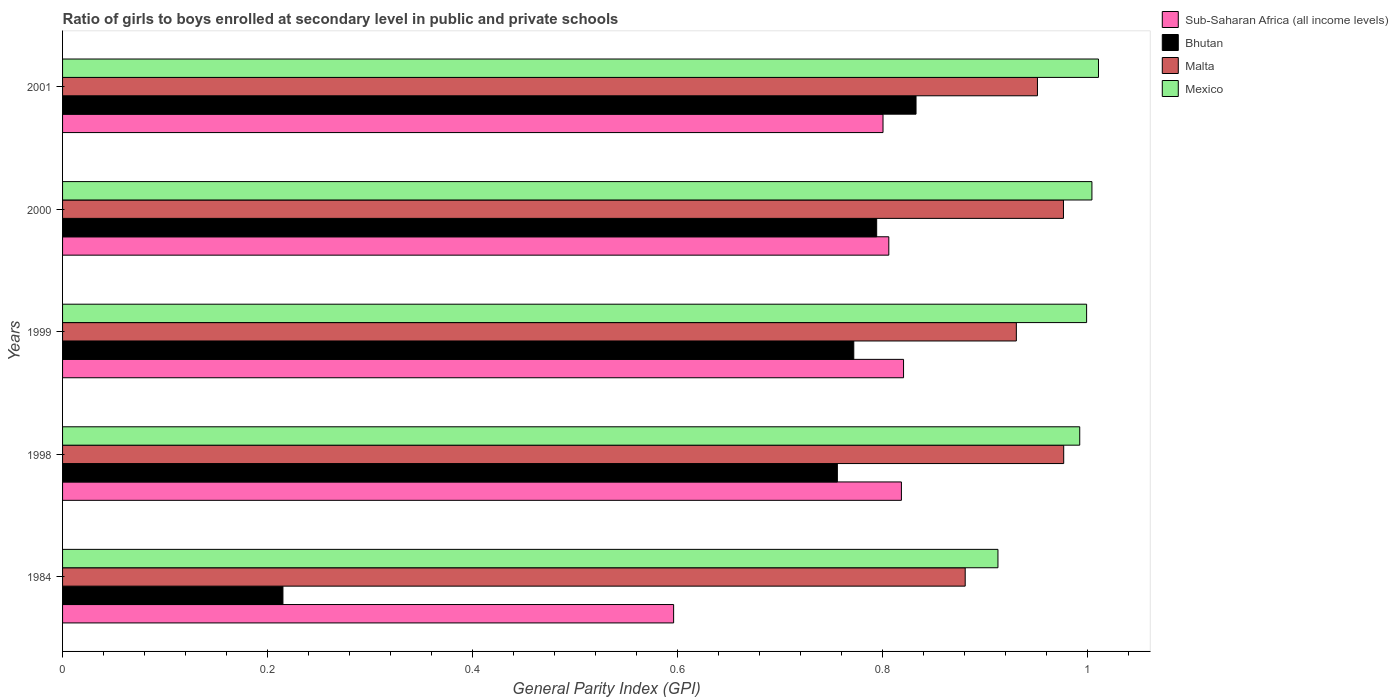How many groups of bars are there?
Your answer should be very brief. 5. Are the number of bars per tick equal to the number of legend labels?
Provide a short and direct response. Yes. What is the general parity index in Mexico in 1998?
Your response must be concise. 0.99. Across all years, what is the maximum general parity index in Sub-Saharan Africa (all income levels)?
Your answer should be very brief. 0.82. Across all years, what is the minimum general parity index in Bhutan?
Your answer should be very brief. 0.21. In which year was the general parity index in Mexico maximum?
Keep it short and to the point. 2001. In which year was the general parity index in Bhutan minimum?
Your response must be concise. 1984. What is the total general parity index in Bhutan in the graph?
Offer a terse response. 3.37. What is the difference between the general parity index in Sub-Saharan Africa (all income levels) in 1998 and that in 2000?
Make the answer very short. 0.01. What is the difference between the general parity index in Mexico in 2000 and the general parity index in Sub-Saharan Africa (all income levels) in 2001?
Make the answer very short. 0.2. What is the average general parity index in Sub-Saharan Africa (all income levels) per year?
Keep it short and to the point. 0.77. In the year 1999, what is the difference between the general parity index in Sub-Saharan Africa (all income levels) and general parity index in Malta?
Offer a terse response. -0.11. What is the ratio of the general parity index in Sub-Saharan Africa (all income levels) in 1998 to that in 2001?
Give a very brief answer. 1.02. Is the general parity index in Sub-Saharan Africa (all income levels) in 1984 less than that in 1999?
Make the answer very short. Yes. What is the difference between the highest and the second highest general parity index in Malta?
Provide a succinct answer. 0. What is the difference between the highest and the lowest general parity index in Malta?
Offer a terse response. 0.1. Is the sum of the general parity index in Mexico in 1998 and 2001 greater than the maximum general parity index in Sub-Saharan Africa (all income levels) across all years?
Your answer should be very brief. Yes. Is it the case that in every year, the sum of the general parity index in Mexico and general parity index in Bhutan is greater than the sum of general parity index in Malta and general parity index in Sub-Saharan Africa (all income levels)?
Your response must be concise. No. What does the 4th bar from the top in 1984 represents?
Make the answer very short. Sub-Saharan Africa (all income levels). What does the 2nd bar from the bottom in 1999 represents?
Provide a short and direct response. Bhutan. Is it the case that in every year, the sum of the general parity index in Bhutan and general parity index in Mexico is greater than the general parity index in Malta?
Keep it short and to the point. Yes. How many bars are there?
Provide a short and direct response. 20. How many years are there in the graph?
Provide a succinct answer. 5. What is the difference between two consecutive major ticks on the X-axis?
Offer a terse response. 0.2. Are the values on the major ticks of X-axis written in scientific E-notation?
Give a very brief answer. No. Does the graph contain any zero values?
Give a very brief answer. No. How are the legend labels stacked?
Give a very brief answer. Vertical. What is the title of the graph?
Your answer should be compact. Ratio of girls to boys enrolled at secondary level in public and private schools. What is the label or title of the X-axis?
Your answer should be very brief. General Parity Index (GPI). What is the General Parity Index (GPI) in Sub-Saharan Africa (all income levels) in 1984?
Offer a terse response. 0.6. What is the General Parity Index (GPI) of Bhutan in 1984?
Offer a terse response. 0.21. What is the General Parity Index (GPI) of Malta in 1984?
Provide a short and direct response. 0.88. What is the General Parity Index (GPI) of Mexico in 1984?
Keep it short and to the point. 0.91. What is the General Parity Index (GPI) in Sub-Saharan Africa (all income levels) in 1998?
Your answer should be very brief. 0.82. What is the General Parity Index (GPI) in Bhutan in 1998?
Make the answer very short. 0.76. What is the General Parity Index (GPI) in Malta in 1998?
Offer a terse response. 0.98. What is the General Parity Index (GPI) in Mexico in 1998?
Provide a succinct answer. 0.99. What is the General Parity Index (GPI) of Sub-Saharan Africa (all income levels) in 1999?
Make the answer very short. 0.82. What is the General Parity Index (GPI) of Bhutan in 1999?
Offer a very short reply. 0.77. What is the General Parity Index (GPI) in Malta in 1999?
Ensure brevity in your answer.  0.93. What is the General Parity Index (GPI) of Mexico in 1999?
Offer a terse response. 1. What is the General Parity Index (GPI) of Sub-Saharan Africa (all income levels) in 2000?
Offer a terse response. 0.81. What is the General Parity Index (GPI) of Bhutan in 2000?
Offer a terse response. 0.79. What is the General Parity Index (GPI) in Malta in 2000?
Make the answer very short. 0.98. What is the General Parity Index (GPI) of Mexico in 2000?
Make the answer very short. 1. What is the General Parity Index (GPI) in Sub-Saharan Africa (all income levels) in 2001?
Your answer should be very brief. 0.8. What is the General Parity Index (GPI) of Bhutan in 2001?
Give a very brief answer. 0.83. What is the General Parity Index (GPI) of Malta in 2001?
Provide a short and direct response. 0.95. What is the General Parity Index (GPI) in Mexico in 2001?
Keep it short and to the point. 1.01. Across all years, what is the maximum General Parity Index (GPI) in Sub-Saharan Africa (all income levels)?
Offer a terse response. 0.82. Across all years, what is the maximum General Parity Index (GPI) of Bhutan?
Offer a terse response. 0.83. Across all years, what is the maximum General Parity Index (GPI) of Malta?
Your answer should be very brief. 0.98. Across all years, what is the maximum General Parity Index (GPI) in Mexico?
Your answer should be compact. 1.01. Across all years, what is the minimum General Parity Index (GPI) of Sub-Saharan Africa (all income levels)?
Your response must be concise. 0.6. Across all years, what is the minimum General Parity Index (GPI) in Bhutan?
Keep it short and to the point. 0.21. Across all years, what is the minimum General Parity Index (GPI) in Malta?
Provide a short and direct response. 0.88. Across all years, what is the minimum General Parity Index (GPI) of Mexico?
Ensure brevity in your answer.  0.91. What is the total General Parity Index (GPI) in Sub-Saharan Africa (all income levels) in the graph?
Your answer should be very brief. 3.84. What is the total General Parity Index (GPI) of Bhutan in the graph?
Offer a very short reply. 3.37. What is the total General Parity Index (GPI) of Malta in the graph?
Give a very brief answer. 4.72. What is the total General Parity Index (GPI) in Mexico in the graph?
Ensure brevity in your answer.  4.92. What is the difference between the General Parity Index (GPI) of Sub-Saharan Africa (all income levels) in 1984 and that in 1998?
Provide a succinct answer. -0.22. What is the difference between the General Parity Index (GPI) of Bhutan in 1984 and that in 1998?
Offer a terse response. -0.54. What is the difference between the General Parity Index (GPI) in Malta in 1984 and that in 1998?
Make the answer very short. -0.1. What is the difference between the General Parity Index (GPI) of Mexico in 1984 and that in 1998?
Your response must be concise. -0.08. What is the difference between the General Parity Index (GPI) in Sub-Saharan Africa (all income levels) in 1984 and that in 1999?
Offer a very short reply. -0.22. What is the difference between the General Parity Index (GPI) of Bhutan in 1984 and that in 1999?
Provide a succinct answer. -0.56. What is the difference between the General Parity Index (GPI) in Malta in 1984 and that in 1999?
Provide a succinct answer. -0.05. What is the difference between the General Parity Index (GPI) in Mexico in 1984 and that in 1999?
Your response must be concise. -0.09. What is the difference between the General Parity Index (GPI) in Sub-Saharan Africa (all income levels) in 1984 and that in 2000?
Your response must be concise. -0.21. What is the difference between the General Parity Index (GPI) in Bhutan in 1984 and that in 2000?
Give a very brief answer. -0.58. What is the difference between the General Parity Index (GPI) in Malta in 1984 and that in 2000?
Provide a succinct answer. -0.1. What is the difference between the General Parity Index (GPI) in Mexico in 1984 and that in 2000?
Provide a short and direct response. -0.09. What is the difference between the General Parity Index (GPI) of Sub-Saharan Africa (all income levels) in 1984 and that in 2001?
Your response must be concise. -0.2. What is the difference between the General Parity Index (GPI) in Bhutan in 1984 and that in 2001?
Offer a very short reply. -0.62. What is the difference between the General Parity Index (GPI) in Malta in 1984 and that in 2001?
Your answer should be very brief. -0.07. What is the difference between the General Parity Index (GPI) of Mexico in 1984 and that in 2001?
Offer a terse response. -0.1. What is the difference between the General Parity Index (GPI) of Sub-Saharan Africa (all income levels) in 1998 and that in 1999?
Keep it short and to the point. -0. What is the difference between the General Parity Index (GPI) of Bhutan in 1998 and that in 1999?
Ensure brevity in your answer.  -0.02. What is the difference between the General Parity Index (GPI) in Malta in 1998 and that in 1999?
Offer a very short reply. 0.05. What is the difference between the General Parity Index (GPI) in Mexico in 1998 and that in 1999?
Provide a short and direct response. -0.01. What is the difference between the General Parity Index (GPI) in Sub-Saharan Africa (all income levels) in 1998 and that in 2000?
Make the answer very short. 0.01. What is the difference between the General Parity Index (GPI) of Bhutan in 1998 and that in 2000?
Make the answer very short. -0.04. What is the difference between the General Parity Index (GPI) in Mexico in 1998 and that in 2000?
Make the answer very short. -0.01. What is the difference between the General Parity Index (GPI) in Sub-Saharan Africa (all income levels) in 1998 and that in 2001?
Make the answer very short. 0.02. What is the difference between the General Parity Index (GPI) of Bhutan in 1998 and that in 2001?
Your answer should be compact. -0.08. What is the difference between the General Parity Index (GPI) in Malta in 1998 and that in 2001?
Your answer should be compact. 0.03. What is the difference between the General Parity Index (GPI) in Mexico in 1998 and that in 2001?
Provide a succinct answer. -0.02. What is the difference between the General Parity Index (GPI) in Sub-Saharan Africa (all income levels) in 1999 and that in 2000?
Keep it short and to the point. 0.01. What is the difference between the General Parity Index (GPI) in Bhutan in 1999 and that in 2000?
Your answer should be compact. -0.02. What is the difference between the General Parity Index (GPI) in Malta in 1999 and that in 2000?
Offer a terse response. -0.05. What is the difference between the General Parity Index (GPI) in Mexico in 1999 and that in 2000?
Your answer should be compact. -0.01. What is the difference between the General Parity Index (GPI) of Bhutan in 1999 and that in 2001?
Provide a succinct answer. -0.06. What is the difference between the General Parity Index (GPI) of Malta in 1999 and that in 2001?
Provide a short and direct response. -0.02. What is the difference between the General Parity Index (GPI) in Mexico in 1999 and that in 2001?
Your answer should be very brief. -0.01. What is the difference between the General Parity Index (GPI) in Sub-Saharan Africa (all income levels) in 2000 and that in 2001?
Give a very brief answer. 0.01. What is the difference between the General Parity Index (GPI) in Bhutan in 2000 and that in 2001?
Offer a very short reply. -0.04. What is the difference between the General Parity Index (GPI) of Malta in 2000 and that in 2001?
Give a very brief answer. 0.03. What is the difference between the General Parity Index (GPI) in Mexico in 2000 and that in 2001?
Provide a short and direct response. -0.01. What is the difference between the General Parity Index (GPI) in Sub-Saharan Africa (all income levels) in 1984 and the General Parity Index (GPI) in Bhutan in 1998?
Make the answer very short. -0.16. What is the difference between the General Parity Index (GPI) in Sub-Saharan Africa (all income levels) in 1984 and the General Parity Index (GPI) in Malta in 1998?
Make the answer very short. -0.38. What is the difference between the General Parity Index (GPI) in Sub-Saharan Africa (all income levels) in 1984 and the General Parity Index (GPI) in Mexico in 1998?
Give a very brief answer. -0.4. What is the difference between the General Parity Index (GPI) in Bhutan in 1984 and the General Parity Index (GPI) in Malta in 1998?
Keep it short and to the point. -0.76. What is the difference between the General Parity Index (GPI) in Bhutan in 1984 and the General Parity Index (GPI) in Mexico in 1998?
Ensure brevity in your answer.  -0.78. What is the difference between the General Parity Index (GPI) of Malta in 1984 and the General Parity Index (GPI) of Mexico in 1998?
Provide a short and direct response. -0.11. What is the difference between the General Parity Index (GPI) in Sub-Saharan Africa (all income levels) in 1984 and the General Parity Index (GPI) in Bhutan in 1999?
Provide a succinct answer. -0.18. What is the difference between the General Parity Index (GPI) of Sub-Saharan Africa (all income levels) in 1984 and the General Parity Index (GPI) of Malta in 1999?
Your response must be concise. -0.33. What is the difference between the General Parity Index (GPI) in Sub-Saharan Africa (all income levels) in 1984 and the General Parity Index (GPI) in Mexico in 1999?
Provide a succinct answer. -0.4. What is the difference between the General Parity Index (GPI) in Bhutan in 1984 and the General Parity Index (GPI) in Malta in 1999?
Your answer should be very brief. -0.72. What is the difference between the General Parity Index (GPI) of Bhutan in 1984 and the General Parity Index (GPI) of Mexico in 1999?
Make the answer very short. -0.78. What is the difference between the General Parity Index (GPI) of Malta in 1984 and the General Parity Index (GPI) of Mexico in 1999?
Ensure brevity in your answer.  -0.12. What is the difference between the General Parity Index (GPI) of Sub-Saharan Africa (all income levels) in 1984 and the General Parity Index (GPI) of Bhutan in 2000?
Your answer should be very brief. -0.2. What is the difference between the General Parity Index (GPI) in Sub-Saharan Africa (all income levels) in 1984 and the General Parity Index (GPI) in Malta in 2000?
Provide a short and direct response. -0.38. What is the difference between the General Parity Index (GPI) in Sub-Saharan Africa (all income levels) in 1984 and the General Parity Index (GPI) in Mexico in 2000?
Ensure brevity in your answer.  -0.41. What is the difference between the General Parity Index (GPI) of Bhutan in 1984 and the General Parity Index (GPI) of Malta in 2000?
Give a very brief answer. -0.76. What is the difference between the General Parity Index (GPI) of Bhutan in 1984 and the General Parity Index (GPI) of Mexico in 2000?
Ensure brevity in your answer.  -0.79. What is the difference between the General Parity Index (GPI) of Malta in 1984 and the General Parity Index (GPI) of Mexico in 2000?
Keep it short and to the point. -0.12. What is the difference between the General Parity Index (GPI) in Sub-Saharan Africa (all income levels) in 1984 and the General Parity Index (GPI) in Bhutan in 2001?
Ensure brevity in your answer.  -0.24. What is the difference between the General Parity Index (GPI) of Sub-Saharan Africa (all income levels) in 1984 and the General Parity Index (GPI) of Malta in 2001?
Keep it short and to the point. -0.35. What is the difference between the General Parity Index (GPI) in Sub-Saharan Africa (all income levels) in 1984 and the General Parity Index (GPI) in Mexico in 2001?
Keep it short and to the point. -0.41. What is the difference between the General Parity Index (GPI) in Bhutan in 1984 and the General Parity Index (GPI) in Malta in 2001?
Ensure brevity in your answer.  -0.74. What is the difference between the General Parity Index (GPI) of Bhutan in 1984 and the General Parity Index (GPI) of Mexico in 2001?
Your answer should be compact. -0.8. What is the difference between the General Parity Index (GPI) of Malta in 1984 and the General Parity Index (GPI) of Mexico in 2001?
Your answer should be very brief. -0.13. What is the difference between the General Parity Index (GPI) in Sub-Saharan Africa (all income levels) in 1998 and the General Parity Index (GPI) in Bhutan in 1999?
Your response must be concise. 0.05. What is the difference between the General Parity Index (GPI) in Sub-Saharan Africa (all income levels) in 1998 and the General Parity Index (GPI) in Malta in 1999?
Provide a short and direct response. -0.11. What is the difference between the General Parity Index (GPI) in Sub-Saharan Africa (all income levels) in 1998 and the General Parity Index (GPI) in Mexico in 1999?
Provide a short and direct response. -0.18. What is the difference between the General Parity Index (GPI) in Bhutan in 1998 and the General Parity Index (GPI) in Malta in 1999?
Your answer should be very brief. -0.17. What is the difference between the General Parity Index (GPI) of Bhutan in 1998 and the General Parity Index (GPI) of Mexico in 1999?
Your response must be concise. -0.24. What is the difference between the General Parity Index (GPI) in Malta in 1998 and the General Parity Index (GPI) in Mexico in 1999?
Offer a very short reply. -0.02. What is the difference between the General Parity Index (GPI) in Sub-Saharan Africa (all income levels) in 1998 and the General Parity Index (GPI) in Bhutan in 2000?
Provide a short and direct response. 0.02. What is the difference between the General Parity Index (GPI) of Sub-Saharan Africa (all income levels) in 1998 and the General Parity Index (GPI) of Malta in 2000?
Make the answer very short. -0.16. What is the difference between the General Parity Index (GPI) of Sub-Saharan Africa (all income levels) in 1998 and the General Parity Index (GPI) of Mexico in 2000?
Make the answer very short. -0.19. What is the difference between the General Parity Index (GPI) of Bhutan in 1998 and the General Parity Index (GPI) of Malta in 2000?
Provide a succinct answer. -0.22. What is the difference between the General Parity Index (GPI) in Bhutan in 1998 and the General Parity Index (GPI) in Mexico in 2000?
Provide a succinct answer. -0.25. What is the difference between the General Parity Index (GPI) in Malta in 1998 and the General Parity Index (GPI) in Mexico in 2000?
Your response must be concise. -0.03. What is the difference between the General Parity Index (GPI) in Sub-Saharan Africa (all income levels) in 1998 and the General Parity Index (GPI) in Bhutan in 2001?
Your answer should be very brief. -0.01. What is the difference between the General Parity Index (GPI) of Sub-Saharan Africa (all income levels) in 1998 and the General Parity Index (GPI) of Malta in 2001?
Your response must be concise. -0.13. What is the difference between the General Parity Index (GPI) in Sub-Saharan Africa (all income levels) in 1998 and the General Parity Index (GPI) in Mexico in 2001?
Offer a very short reply. -0.19. What is the difference between the General Parity Index (GPI) of Bhutan in 1998 and the General Parity Index (GPI) of Malta in 2001?
Make the answer very short. -0.2. What is the difference between the General Parity Index (GPI) of Bhutan in 1998 and the General Parity Index (GPI) of Mexico in 2001?
Ensure brevity in your answer.  -0.25. What is the difference between the General Parity Index (GPI) of Malta in 1998 and the General Parity Index (GPI) of Mexico in 2001?
Keep it short and to the point. -0.03. What is the difference between the General Parity Index (GPI) of Sub-Saharan Africa (all income levels) in 1999 and the General Parity Index (GPI) of Bhutan in 2000?
Your answer should be very brief. 0.03. What is the difference between the General Parity Index (GPI) in Sub-Saharan Africa (all income levels) in 1999 and the General Parity Index (GPI) in Malta in 2000?
Your answer should be very brief. -0.16. What is the difference between the General Parity Index (GPI) in Sub-Saharan Africa (all income levels) in 1999 and the General Parity Index (GPI) in Mexico in 2000?
Offer a terse response. -0.18. What is the difference between the General Parity Index (GPI) of Bhutan in 1999 and the General Parity Index (GPI) of Malta in 2000?
Offer a terse response. -0.2. What is the difference between the General Parity Index (GPI) of Bhutan in 1999 and the General Parity Index (GPI) of Mexico in 2000?
Provide a short and direct response. -0.23. What is the difference between the General Parity Index (GPI) in Malta in 1999 and the General Parity Index (GPI) in Mexico in 2000?
Your response must be concise. -0.07. What is the difference between the General Parity Index (GPI) of Sub-Saharan Africa (all income levels) in 1999 and the General Parity Index (GPI) of Bhutan in 2001?
Your response must be concise. -0.01. What is the difference between the General Parity Index (GPI) in Sub-Saharan Africa (all income levels) in 1999 and the General Parity Index (GPI) in Malta in 2001?
Your answer should be compact. -0.13. What is the difference between the General Parity Index (GPI) in Sub-Saharan Africa (all income levels) in 1999 and the General Parity Index (GPI) in Mexico in 2001?
Provide a succinct answer. -0.19. What is the difference between the General Parity Index (GPI) in Bhutan in 1999 and the General Parity Index (GPI) in Malta in 2001?
Your answer should be very brief. -0.18. What is the difference between the General Parity Index (GPI) in Bhutan in 1999 and the General Parity Index (GPI) in Mexico in 2001?
Give a very brief answer. -0.24. What is the difference between the General Parity Index (GPI) of Malta in 1999 and the General Parity Index (GPI) of Mexico in 2001?
Make the answer very short. -0.08. What is the difference between the General Parity Index (GPI) in Sub-Saharan Africa (all income levels) in 2000 and the General Parity Index (GPI) in Bhutan in 2001?
Offer a very short reply. -0.03. What is the difference between the General Parity Index (GPI) of Sub-Saharan Africa (all income levels) in 2000 and the General Parity Index (GPI) of Malta in 2001?
Your answer should be compact. -0.14. What is the difference between the General Parity Index (GPI) in Sub-Saharan Africa (all income levels) in 2000 and the General Parity Index (GPI) in Mexico in 2001?
Provide a succinct answer. -0.2. What is the difference between the General Parity Index (GPI) of Bhutan in 2000 and the General Parity Index (GPI) of Malta in 2001?
Your answer should be very brief. -0.16. What is the difference between the General Parity Index (GPI) of Bhutan in 2000 and the General Parity Index (GPI) of Mexico in 2001?
Keep it short and to the point. -0.22. What is the difference between the General Parity Index (GPI) in Malta in 2000 and the General Parity Index (GPI) in Mexico in 2001?
Your answer should be very brief. -0.03. What is the average General Parity Index (GPI) in Sub-Saharan Africa (all income levels) per year?
Provide a short and direct response. 0.77. What is the average General Parity Index (GPI) of Bhutan per year?
Make the answer very short. 0.67. What is the average General Parity Index (GPI) in Malta per year?
Give a very brief answer. 0.94. What is the average General Parity Index (GPI) of Mexico per year?
Provide a succinct answer. 0.98. In the year 1984, what is the difference between the General Parity Index (GPI) of Sub-Saharan Africa (all income levels) and General Parity Index (GPI) of Bhutan?
Offer a terse response. 0.38. In the year 1984, what is the difference between the General Parity Index (GPI) in Sub-Saharan Africa (all income levels) and General Parity Index (GPI) in Malta?
Your answer should be very brief. -0.28. In the year 1984, what is the difference between the General Parity Index (GPI) of Sub-Saharan Africa (all income levels) and General Parity Index (GPI) of Mexico?
Offer a very short reply. -0.32. In the year 1984, what is the difference between the General Parity Index (GPI) of Bhutan and General Parity Index (GPI) of Malta?
Provide a succinct answer. -0.67. In the year 1984, what is the difference between the General Parity Index (GPI) in Bhutan and General Parity Index (GPI) in Mexico?
Offer a terse response. -0.7. In the year 1984, what is the difference between the General Parity Index (GPI) in Malta and General Parity Index (GPI) in Mexico?
Offer a terse response. -0.03. In the year 1998, what is the difference between the General Parity Index (GPI) of Sub-Saharan Africa (all income levels) and General Parity Index (GPI) of Bhutan?
Give a very brief answer. 0.06. In the year 1998, what is the difference between the General Parity Index (GPI) in Sub-Saharan Africa (all income levels) and General Parity Index (GPI) in Malta?
Ensure brevity in your answer.  -0.16. In the year 1998, what is the difference between the General Parity Index (GPI) in Sub-Saharan Africa (all income levels) and General Parity Index (GPI) in Mexico?
Keep it short and to the point. -0.17. In the year 1998, what is the difference between the General Parity Index (GPI) in Bhutan and General Parity Index (GPI) in Malta?
Ensure brevity in your answer.  -0.22. In the year 1998, what is the difference between the General Parity Index (GPI) in Bhutan and General Parity Index (GPI) in Mexico?
Provide a short and direct response. -0.24. In the year 1998, what is the difference between the General Parity Index (GPI) of Malta and General Parity Index (GPI) of Mexico?
Provide a short and direct response. -0.02. In the year 1999, what is the difference between the General Parity Index (GPI) of Sub-Saharan Africa (all income levels) and General Parity Index (GPI) of Bhutan?
Provide a short and direct response. 0.05. In the year 1999, what is the difference between the General Parity Index (GPI) in Sub-Saharan Africa (all income levels) and General Parity Index (GPI) in Malta?
Keep it short and to the point. -0.11. In the year 1999, what is the difference between the General Parity Index (GPI) in Sub-Saharan Africa (all income levels) and General Parity Index (GPI) in Mexico?
Provide a short and direct response. -0.18. In the year 1999, what is the difference between the General Parity Index (GPI) in Bhutan and General Parity Index (GPI) in Malta?
Provide a short and direct response. -0.16. In the year 1999, what is the difference between the General Parity Index (GPI) of Bhutan and General Parity Index (GPI) of Mexico?
Your response must be concise. -0.23. In the year 1999, what is the difference between the General Parity Index (GPI) of Malta and General Parity Index (GPI) of Mexico?
Ensure brevity in your answer.  -0.07. In the year 2000, what is the difference between the General Parity Index (GPI) in Sub-Saharan Africa (all income levels) and General Parity Index (GPI) in Bhutan?
Ensure brevity in your answer.  0.01. In the year 2000, what is the difference between the General Parity Index (GPI) of Sub-Saharan Africa (all income levels) and General Parity Index (GPI) of Malta?
Offer a terse response. -0.17. In the year 2000, what is the difference between the General Parity Index (GPI) of Sub-Saharan Africa (all income levels) and General Parity Index (GPI) of Mexico?
Your answer should be very brief. -0.2. In the year 2000, what is the difference between the General Parity Index (GPI) of Bhutan and General Parity Index (GPI) of Malta?
Keep it short and to the point. -0.18. In the year 2000, what is the difference between the General Parity Index (GPI) of Bhutan and General Parity Index (GPI) of Mexico?
Provide a succinct answer. -0.21. In the year 2000, what is the difference between the General Parity Index (GPI) of Malta and General Parity Index (GPI) of Mexico?
Make the answer very short. -0.03. In the year 2001, what is the difference between the General Parity Index (GPI) of Sub-Saharan Africa (all income levels) and General Parity Index (GPI) of Bhutan?
Provide a succinct answer. -0.03. In the year 2001, what is the difference between the General Parity Index (GPI) in Sub-Saharan Africa (all income levels) and General Parity Index (GPI) in Malta?
Make the answer very short. -0.15. In the year 2001, what is the difference between the General Parity Index (GPI) of Sub-Saharan Africa (all income levels) and General Parity Index (GPI) of Mexico?
Give a very brief answer. -0.21. In the year 2001, what is the difference between the General Parity Index (GPI) of Bhutan and General Parity Index (GPI) of Malta?
Provide a succinct answer. -0.12. In the year 2001, what is the difference between the General Parity Index (GPI) of Bhutan and General Parity Index (GPI) of Mexico?
Provide a short and direct response. -0.18. In the year 2001, what is the difference between the General Parity Index (GPI) of Malta and General Parity Index (GPI) of Mexico?
Ensure brevity in your answer.  -0.06. What is the ratio of the General Parity Index (GPI) of Sub-Saharan Africa (all income levels) in 1984 to that in 1998?
Provide a short and direct response. 0.73. What is the ratio of the General Parity Index (GPI) in Bhutan in 1984 to that in 1998?
Offer a terse response. 0.28. What is the ratio of the General Parity Index (GPI) in Malta in 1984 to that in 1998?
Make the answer very short. 0.9. What is the ratio of the General Parity Index (GPI) of Mexico in 1984 to that in 1998?
Provide a short and direct response. 0.92. What is the ratio of the General Parity Index (GPI) of Sub-Saharan Africa (all income levels) in 1984 to that in 1999?
Your response must be concise. 0.73. What is the ratio of the General Parity Index (GPI) in Bhutan in 1984 to that in 1999?
Provide a succinct answer. 0.28. What is the ratio of the General Parity Index (GPI) of Malta in 1984 to that in 1999?
Provide a short and direct response. 0.95. What is the ratio of the General Parity Index (GPI) of Mexico in 1984 to that in 1999?
Provide a succinct answer. 0.91. What is the ratio of the General Parity Index (GPI) of Sub-Saharan Africa (all income levels) in 1984 to that in 2000?
Your answer should be compact. 0.74. What is the ratio of the General Parity Index (GPI) of Bhutan in 1984 to that in 2000?
Give a very brief answer. 0.27. What is the ratio of the General Parity Index (GPI) in Malta in 1984 to that in 2000?
Your response must be concise. 0.9. What is the ratio of the General Parity Index (GPI) in Mexico in 1984 to that in 2000?
Give a very brief answer. 0.91. What is the ratio of the General Parity Index (GPI) of Sub-Saharan Africa (all income levels) in 1984 to that in 2001?
Keep it short and to the point. 0.74. What is the ratio of the General Parity Index (GPI) in Bhutan in 1984 to that in 2001?
Your answer should be very brief. 0.26. What is the ratio of the General Parity Index (GPI) in Malta in 1984 to that in 2001?
Provide a short and direct response. 0.93. What is the ratio of the General Parity Index (GPI) in Mexico in 1984 to that in 2001?
Provide a short and direct response. 0.9. What is the ratio of the General Parity Index (GPI) in Sub-Saharan Africa (all income levels) in 1998 to that in 1999?
Offer a very short reply. 1. What is the ratio of the General Parity Index (GPI) in Bhutan in 1998 to that in 1999?
Your response must be concise. 0.98. What is the ratio of the General Parity Index (GPI) in Malta in 1998 to that in 1999?
Ensure brevity in your answer.  1.05. What is the ratio of the General Parity Index (GPI) of Sub-Saharan Africa (all income levels) in 1998 to that in 2000?
Offer a terse response. 1.02. What is the ratio of the General Parity Index (GPI) in Bhutan in 1998 to that in 2000?
Offer a very short reply. 0.95. What is the ratio of the General Parity Index (GPI) of Malta in 1998 to that in 2000?
Ensure brevity in your answer.  1. What is the ratio of the General Parity Index (GPI) in Mexico in 1998 to that in 2000?
Offer a very short reply. 0.99. What is the ratio of the General Parity Index (GPI) of Sub-Saharan Africa (all income levels) in 1998 to that in 2001?
Keep it short and to the point. 1.02. What is the ratio of the General Parity Index (GPI) in Bhutan in 1998 to that in 2001?
Provide a short and direct response. 0.91. What is the ratio of the General Parity Index (GPI) of Malta in 1998 to that in 2001?
Your response must be concise. 1.03. What is the ratio of the General Parity Index (GPI) of Mexico in 1998 to that in 2001?
Provide a succinct answer. 0.98. What is the ratio of the General Parity Index (GPI) in Sub-Saharan Africa (all income levels) in 1999 to that in 2000?
Provide a short and direct response. 1.02. What is the ratio of the General Parity Index (GPI) in Bhutan in 1999 to that in 2000?
Ensure brevity in your answer.  0.97. What is the ratio of the General Parity Index (GPI) in Malta in 1999 to that in 2000?
Offer a terse response. 0.95. What is the ratio of the General Parity Index (GPI) of Sub-Saharan Africa (all income levels) in 1999 to that in 2001?
Provide a short and direct response. 1.02. What is the ratio of the General Parity Index (GPI) in Bhutan in 1999 to that in 2001?
Provide a short and direct response. 0.93. What is the ratio of the General Parity Index (GPI) of Malta in 1999 to that in 2001?
Offer a very short reply. 0.98. What is the ratio of the General Parity Index (GPI) in Mexico in 1999 to that in 2001?
Provide a succinct answer. 0.99. What is the ratio of the General Parity Index (GPI) of Sub-Saharan Africa (all income levels) in 2000 to that in 2001?
Provide a short and direct response. 1.01. What is the ratio of the General Parity Index (GPI) of Bhutan in 2000 to that in 2001?
Provide a short and direct response. 0.95. What is the ratio of the General Parity Index (GPI) in Malta in 2000 to that in 2001?
Make the answer very short. 1.03. What is the ratio of the General Parity Index (GPI) in Mexico in 2000 to that in 2001?
Offer a terse response. 0.99. What is the difference between the highest and the second highest General Parity Index (GPI) in Sub-Saharan Africa (all income levels)?
Your response must be concise. 0. What is the difference between the highest and the second highest General Parity Index (GPI) of Bhutan?
Your answer should be very brief. 0.04. What is the difference between the highest and the second highest General Parity Index (GPI) of Mexico?
Your response must be concise. 0.01. What is the difference between the highest and the lowest General Parity Index (GPI) in Sub-Saharan Africa (all income levels)?
Provide a short and direct response. 0.22. What is the difference between the highest and the lowest General Parity Index (GPI) of Bhutan?
Ensure brevity in your answer.  0.62. What is the difference between the highest and the lowest General Parity Index (GPI) in Malta?
Ensure brevity in your answer.  0.1. What is the difference between the highest and the lowest General Parity Index (GPI) of Mexico?
Your answer should be very brief. 0.1. 